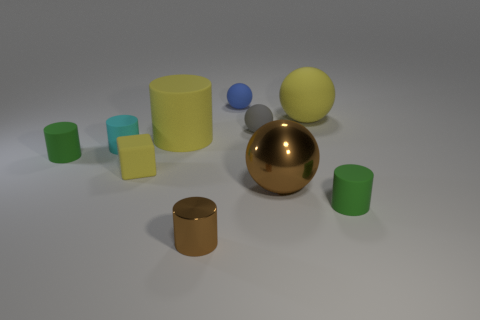What is the shape of the tiny brown metallic thing?
Provide a succinct answer. Cylinder. What number of other things are there of the same material as the small brown thing
Your answer should be compact. 1. Do the cyan matte object and the yellow rubber ball have the same size?
Keep it short and to the point. No. The brown shiny object that is to the right of the gray matte object has what shape?
Offer a very short reply. Sphere. There is a ball in front of the green thing that is on the left side of the cyan object; what color is it?
Give a very brief answer. Brown. Is the shape of the tiny green thing that is to the right of the yellow matte cube the same as the big yellow thing that is right of the small brown thing?
Give a very brief answer. No. There is a yellow object that is the same size as the blue ball; what is its shape?
Make the answer very short. Cube. The big ball that is made of the same material as the tiny cyan object is what color?
Your answer should be very brief. Yellow. There is a big metallic object; is it the same shape as the small blue matte thing right of the big matte cylinder?
Your answer should be compact. Yes. What is the material of the large sphere that is the same color as the big cylinder?
Your answer should be compact. Rubber. 